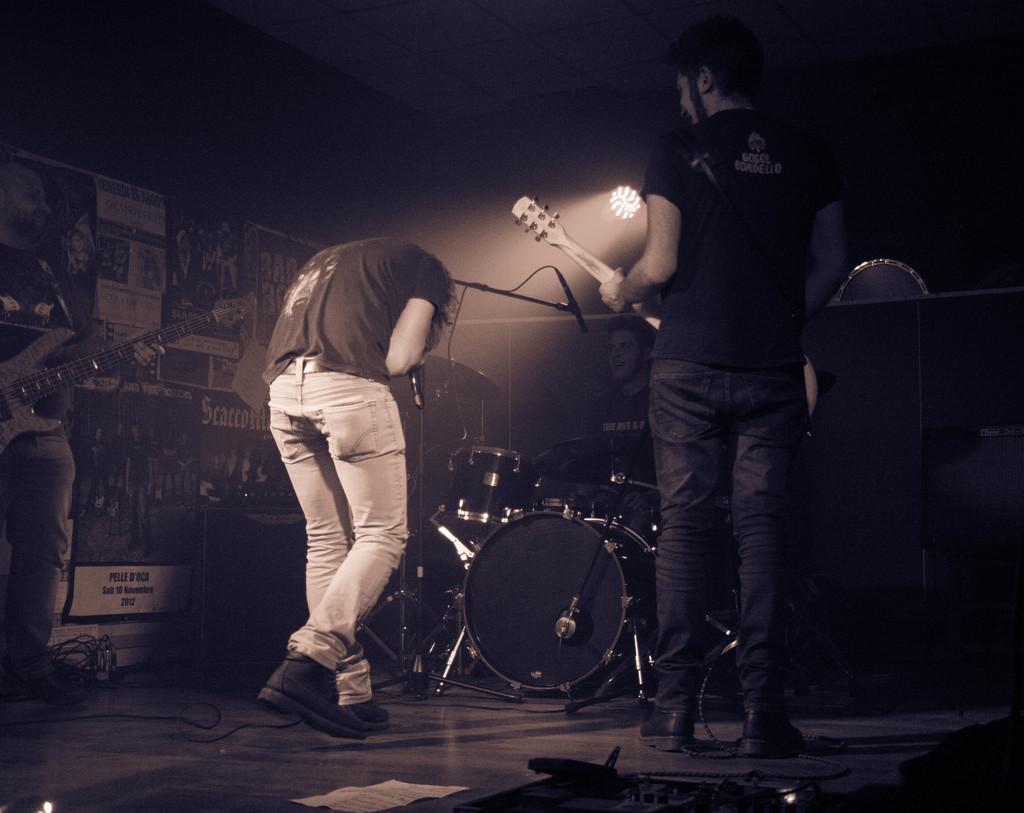What type of performance is happening in the image? A rock band is performing in the image. What instrument is the man at the back playing? The man at the back is playing drums. What is the man in the center doing? The man bent is singing. How many guitarists are there in the band? There are two men on either side playing the guitar. Reasoning: Let'ing: Let's think step by step in order to produce the conversation. We start by identifying the main subject of the image, which is a rock band performing. Then, we describe the roles of each band member, focusing on the instruments they are playing and their actions during the performance. Each question is designed to elicit a specific detail about the image that is known from the provided facts. Absurd Question/Answer: What type of crime is being committed by the guitarist on the left side of the image? There is no crime being committed in the image; it features a rock band performing. How often does the band wash their instruments after each performance? The frequency of washing instruments is not mentioned in the image, and it is not possible to determine this information based on the provided facts. What type of crime is being committed by the guitarist on the left side of the image? There is no crime being committed in the image; it features a rock band performing. How often does the band wash their instruments after each performance? The frequency of washing instruments is not mentioned in the image, and it is not possible to determine this information based on the provided facts. 